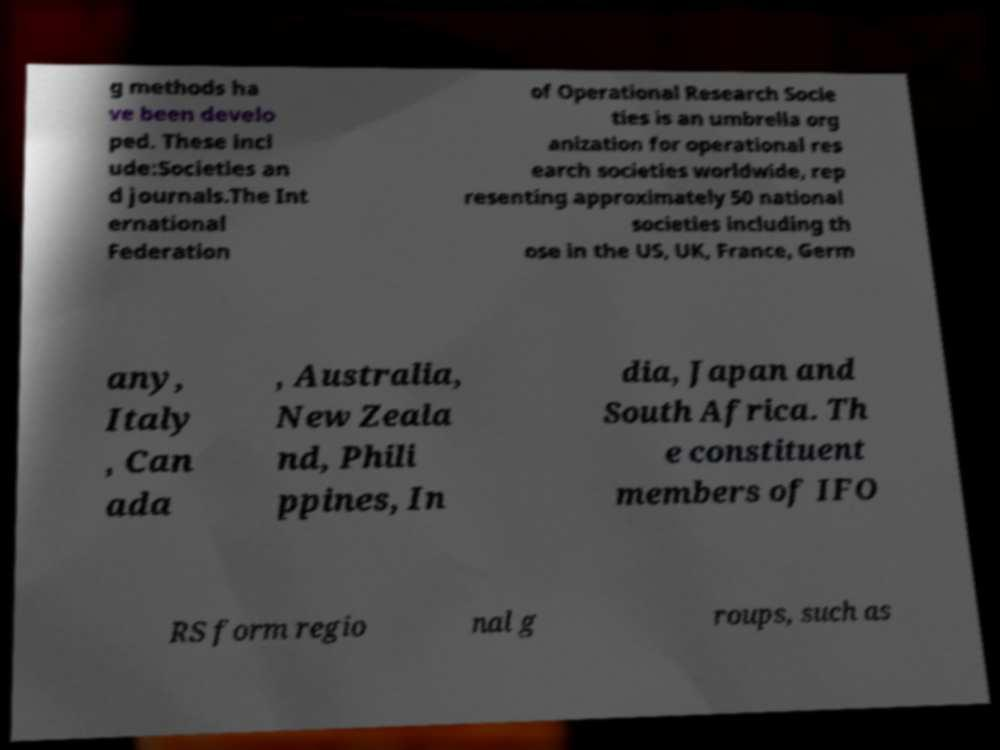Could you assist in decoding the text presented in this image and type it out clearly? g methods ha ve been develo ped. These incl ude:Societies an d journals.The Int ernational Federation of Operational Research Socie ties is an umbrella org anization for operational res earch societies worldwide, rep resenting approximately 50 national societies including th ose in the US, UK, France, Germ any, Italy , Can ada , Australia, New Zeala nd, Phili ppines, In dia, Japan and South Africa. Th e constituent members of IFO RS form regio nal g roups, such as 